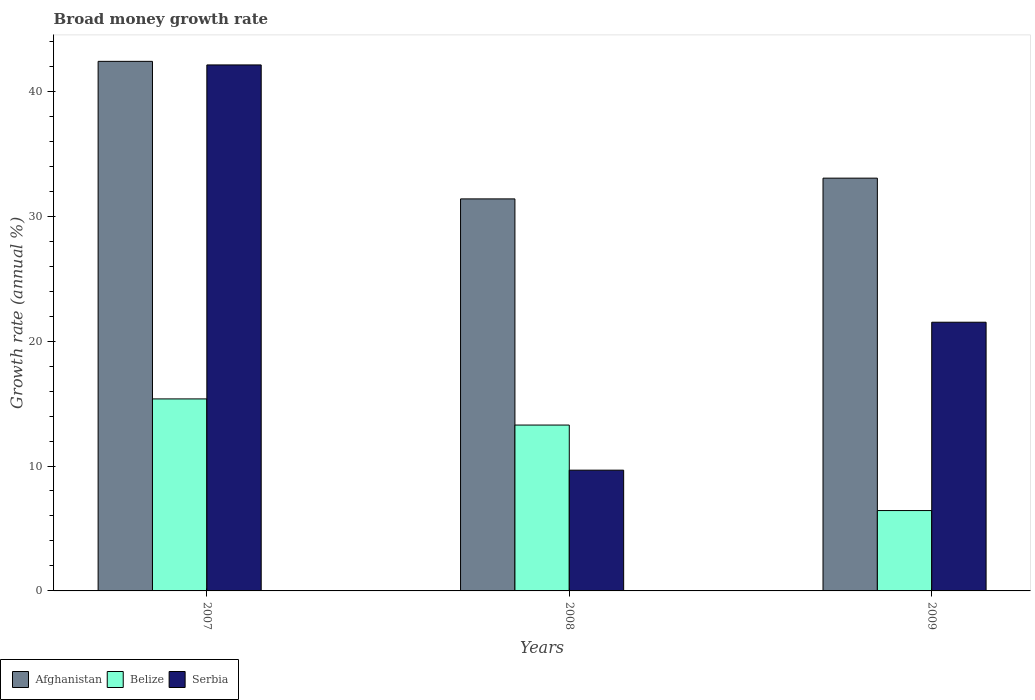How many groups of bars are there?
Offer a terse response. 3. Are the number of bars on each tick of the X-axis equal?
Give a very brief answer. Yes. How many bars are there on the 2nd tick from the right?
Offer a terse response. 3. In how many cases, is the number of bars for a given year not equal to the number of legend labels?
Ensure brevity in your answer.  0. What is the growth rate in Belize in 2009?
Offer a terse response. 6.43. Across all years, what is the maximum growth rate in Serbia?
Give a very brief answer. 42.11. Across all years, what is the minimum growth rate in Afghanistan?
Your answer should be compact. 31.38. What is the total growth rate in Belize in the graph?
Make the answer very short. 35.08. What is the difference between the growth rate in Serbia in 2008 and that in 2009?
Keep it short and to the point. -11.84. What is the difference between the growth rate in Belize in 2007 and the growth rate in Afghanistan in 2009?
Make the answer very short. -17.67. What is the average growth rate in Serbia per year?
Provide a succinct answer. 24.43. In the year 2009, what is the difference between the growth rate in Belize and growth rate in Afghanistan?
Your answer should be very brief. -26.61. What is the ratio of the growth rate in Serbia in 2007 to that in 2009?
Ensure brevity in your answer.  1.96. Is the growth rate in Serbia in 2007 less than that in 2009?
Ensure brevity in your answer.  No. What is the difference between the highest and the second highest growth rate in Afghanistan?
Offer a very short reply. 9.35. What is the difference between the highest and the lowest growth rate in Afghanistan?
Your response must be concise. 11.01. In how many years, is the growth rate in Afghanistan greater than the average growth rate in Afghanistan taken over all years?
Ensure brevity in your answer.  1. Is the sum of the growth rate in Belize in 2008 and 2009 greater than the maximum growth rate in Afghanistan across all years?
Provide a succinct answer. No. What does the 1st bar from the left in 2007 represents?
Ensure brevity in your answer.  Afghanistan. What does the 2nd bar from the right in 2009 represents?
Provide a succinct answer. Belize. Is it the case that in every year, the sum of the growth rate in Afghanistan and growth rate in Belize is greater than the growth rate in Serbia?
Offer a terse response. Yes. What is the difference between two consecutive major ticks on the Y-axis?
Make the answer very short. 10. Are the values on the major ticks of Y-axis written in scientific E-notation?
Ensure brevity in your answer.  No. Does the graph contain any zero values?
Give a very brief answer. No. Does the graph contain grids?
Your response must be concise. No. Where does the legend appear in the graph?
Provide a short and direct response. Bottom left. How are the legend labels stacked?
Your answer should be compact. Horizontal. What is the title of the graph?
Your answer should be very brief. Broad money growth rate. What is the label or title of the Y-axis?
Keep it short and to the point. Growth rate (annual %). What is the Growth rate (annual %) in Afghanistan in 2007?
Offer a very short reply. 42.4. What is the Growth rate (annual %) of Belize in 2007?
Keep it short and to the point. 15.37. What is the Growth rate (annual %) in Serbia in 2007?
Your answer should be very brief. 42.11. What is the Growth rate (annual %) of Afghanistan in 2008?
Your answer should be compact. 31.38. What is the Growth rate (annual %) in Belize in 2008?
Provide a succinct answer. 13.28. What is the Growth rate (annual %) in Serbia in 2008?
Keep it short and to the point. 9.67. What is the Growth rate (annual %) in Afghanistan in 2009?
Make the answer very short. 33.05. What is the Growth rate (annual %) of Belize in 2009?
Your answer should be very brief. 6.43. What is the Growth rate (annual %) of Serbia in 2009?
Your answer should be compact. 21.51. Across all years, what is the maximum Growth rate (annual %) in Afghanistan?
Your answer should be compact. 42.4. Across all years, what is the maximum Growth rate (annual %) in Belize?
Your response must be concise. 15.37. Across all years, what is the maximum Growth rate (annual %) of Serbia?
Offer a very short reply. 42.11. Across all years, what is the minimum Growth rate (annual %) in Afghanistan?
Offer a very short reply. 31.38. Across all years, what is the minimum Growth rate (annual %) in Belize?
Provide a succinct answer. 6.43. Across all years, what is the minimum Growth rate (annual %) of Serbia?
Keep it short and to the point. 9.67. What is the total Growth rate (annual %) in Afghanistan in the graph?
Offer a very short reply. 106.82. What is the total Growth rate (annual %) in Belize in the graph?
Provide a short and direct response. 35.08. What is the total Growth rate (annual %) in Serbia in the graph?
Your answer should be compact. 73.29. What is the difference between the Growth rate (annual %) in Afghanistan in 2007 and that in 2008?
Give a very brief answer. 11.01. What is the difference between the Growth rate (annual %) of Belize in 2007 and that in 2008?
Make the answer very short. 2.09. What is the difference between the Growth rate (annual %) of Serbia in 2007 and that in 2008?
Keep it short and to the point. 32.44. What is the difference between the Growth rate (annual %) in Afghanistan in 2007 and that in 2009?
Offer a very short reply. 9.35. What is the difference between the Growth rate (annual %) of Belize in 2007 and that in 2009?
Your answer should be very brief. 8.94. What is the difference between the Growth rate (annual %) of Serbia in 2007 and that in 2009?
Your answer should be compact. 20.6. What is the difference between the Growth rate (annual %) of Afghanistan in 2008 and that in 2009?
Make the answer very short. -1.66. What is the difference between the Growth rate (annual %) in Belize in 2008 and that in 2009?
Make the answer very short. 6.84. What is the difference between the Growth rate (annual %) of Serbia in 2008 and that in 2009?
Make the answer very short. -11.84. What is the difference between the Growth rate (annual %) in Afghanistan in 2007 and the Growth rate (annual %) in Belize in 2008?
Ensure brevity in your answer.  29.12. What is the difference between the Growth rate (annual %) in Afghanistan in 2007 and the Growth rate (annual %) in Serbia in 2008?
Give a very brief answer. 32.73. What is the difference between the Growth rate (annual %) in Belize in 2007 and the Growth rate (annual %) in Serbia in 2008?
Offer a terse response. 5.7. What is the difference between the Growth rate (annual %) of Afghanistan in 2007 and the Growth rate (annual %) of Belize in 2009?
Your answer should be compact. 35.96. What is the difference between the Growth rate (annual %) in Afghanistan in 2007 and the Growth rate (annual %) in Serbia in 2009?
Your answer should be very brief. 20.88. What is the difference between the Growth rate (annual %) of Belize in 2007 and the Growth rate (annual %) of Serbia in 2009?
Provide a succinct answer. -6.14. What is the difference between the Growth rate (annual %) of Afghanistan in 2008 and the Growth rate (annual %) of Belize in 2009?
Keep it short and to the point. 24.95. What is the difference between the Growth rate (annual %) of Afghanistan in 2008 and the Growth rate (annual %) of Serbia in 2009?
Provide a succinct answer. 9.87. What is the difference between the Growth rate (annual %) in Belize in 2008 and the Growth rate (annual %) in Serbia in 2009?
Your answer should be very brief. -8.23. What is the average Growth rate (annual %) of Afghanistan per year?
Your answer should be very brief. 35.61. What is the average Growth rate (annual %) of Belize per year?
Ensure brevity in your answer.  11.69. What is the average Growth rate (annual %) in Serbia per year?
Offer a terse response. 24.43. In the year 2007, what is the difference between the Growth rate (annual %) in Afghanistan and Growth rate (annual %) in Belize?
Provide a short and direct response. 27.02. In the year 2007, what is the difference between the Growth rate (annual %) of Afghanistan and Growth rate (annual %) of Serbia?
Offer a very short reply. 0.29. In the year 2007, what is the difference between the Growth rate (annual %) in Belize and Growth rate (annual %) in Serbia?
Ensure brevity in your answer.  -26.74. In the year 2008, what is the difference between the Growth rate (annual %) of Afghanistan and Growth rate (annual %) of Belize?
Offer a very short reply. 18.1. In the year 2008, what is the difference between the Growth rate (annual %) of Afghanistan and Growth rate (annual %) of Serbia?
Offer a terse response. 21.72. In the year 2008, what is the difference between the Growth rate (annual %) of Belize and Growth rate (annual %) of Serbia?
Give a very brief answer. 3.61. In the year 2009, what is the difference between the Growth rate (annual %) in Afghanistan and Growth rate (annual %) in Belize?
Your answer should be compact. 26.61. In the year 2009, what is the difference between the Growth rate (annual %) of Afghanistan and Growth rate (annual %) of Serbia?
Provide a short and direct response. 11.53. In the year 2009, what is the difference between the Growth rate (annual %) in Belize and Growth rate (annual %) in Serbia?
Offer a terse response. -15.08. What is the ratio of the Growth rate (annual %) in Afghanistan in 2007 to that in 2008?
Ensure brevity in your answer.  1.35. What is the ratio of the Growth rate (annual %) in Belize in 2007 to that in 2008?
Provide a succinct answer. 1.16. What is the ratio of the Growth rate (annual %) in Serbia in 2007 to that in 2008?
Offer a terse response. 4.36. What is the ratio of the Growth rate (annual %) in Afghanistan in 2007 to that in 2009?
Provide a succinct answer. 1.28. What is the ratio of the Growth rate (annual %) in Belize in 2007 to that in 2009?
Your answer should be very brief. 2.39. What is the ratio of the Growth rate (annual %) in Serbia in 2007 to that in 2009?
Give a very brief answer. 1.96. What is the ratio of the Growth rate (annual %) of Afghanistan in 2008 to that in 2009?
Offer a very short reply. 0.95. What is the ratio of the Growth rate (annual %) in Belize in 2008 to that in 2009?
Offer a terse response. 2.06. What is the ratio of the Growth rate (annual %) of Serbia in 2008 to that in 2009?
Give a very brief answer. 0.45. What is the difference between the highest and the second highest Growth rate (annual %) of Afghanistan?
Your response must be concise. 9.35. What is the difference between the highest and the second highest Growth rate (annual %) of Belize?
Give a very brief answer. 2.09. What is the difference between the highest and the second highest Growth rate (annual %) of Serbia?
Make the answer very short. 20.6. What is the difference between the highest and the lowest Growth rate (annual %) of Afghanistan?
Your answer should be compact. 11.01. What is the difference between the highest and the lowest Growth rate (annual %) of Belize?
Make the answer very short. 8.94. What is the difference between the highest and the lowest Growth rate (annual %) of Serbia?
Your answer should be very brief. 32.44. 